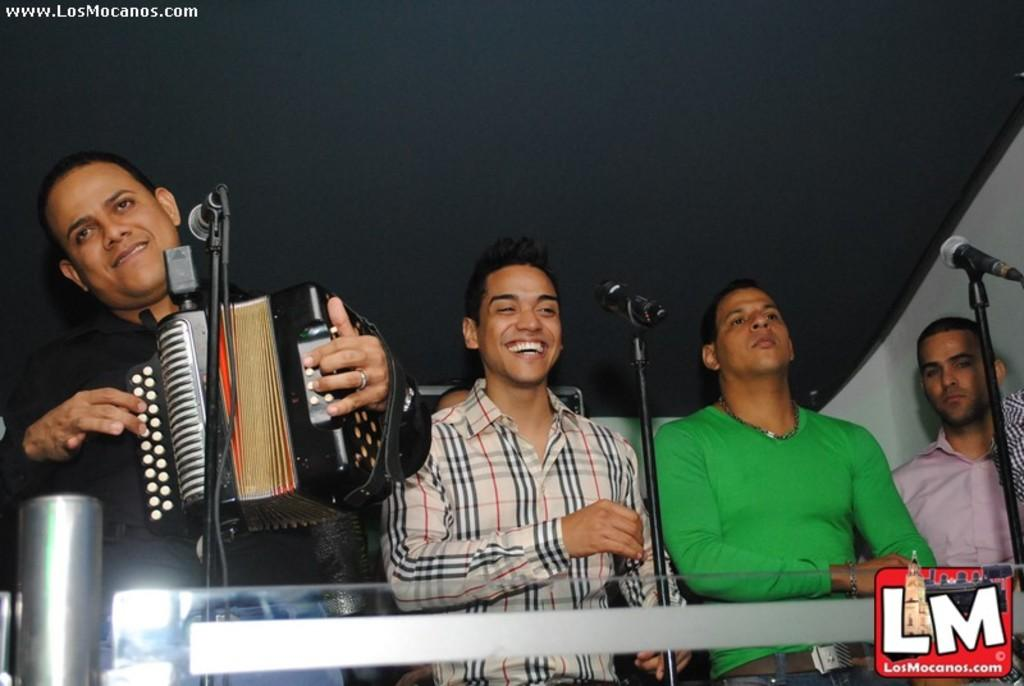What are the people in the image doing? The people in the image are standing in front of microphones. What activity is the man engaged in? The man is playing a musical instrument. Can you describe any visual elements on the image? Yes, there is a logo and a watermark on the image. Where is the basket of goldfish located in the image? There is no basket of goldfish present in the image. What type of seed can be seen growing near the microphones? There is no seed visible in the image. 